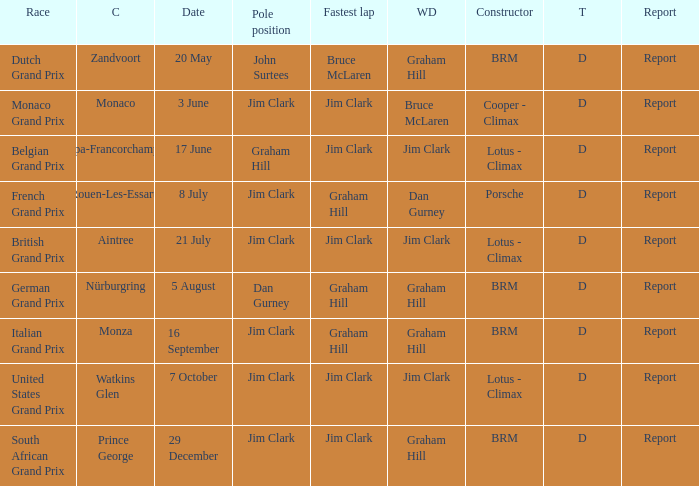What is the constructor at the United States Grand Prix? Lotus - Climax. Write the full table. {'header': ['Race', 'C', 'Date', 'Pole position', 'Fastest lap', 'WD', 'Constructor', 'T', 'Report'], 'rows': [['Dutch Grand Prix', 'Zandvoort', '20 May', 'John Surtees', 'Bruce McLaren', 'Graham Hill', 'BRM', 'D', 'Report'], ['Monaco Grand Prix', 'Monaco', '3 June', 'Jim Clark', 'Jim Clark', 'Bruce McLaren', 'Cooper - Climax', 'D', 'Report'], ['Belgian Grand Prix', 'Spa-Francorchamps', '17 June', 'Graham Hill', 'Jim Clark', 'Jim Clark', 'Lotus - Climax', 'D', 'Report'], ['French Grand Prix', 'Rouen-Les-Essarts', '8 July', 'Jim Clark', 'Graham Hill', 'Dan Gurney', 'Porsche', 'D', 'Report'], ['British Grand Prix', 'Aintree', '21 July', 'Jim Clark', 'Jim Clark', 'Jim Clark', 'Lotus - Climax', 'D', 'Report'], ['German Grand Prix', 'Nürburgring', '5 August', 'Dan Gurney', 'Graham Hill', 'Graham Hill', 'BRM', 'D', 'Report'], ['Italian Grand Prix', 'Monza', '16 September', 'Jim Clark', 'Graham Hill', 'Graham Hill', 'BRM', 'D', 'Report'], ['United States Grand Prix', 'Watkins Glen', '7 October', 'Jim Clark', 'Jim Clark', 'Jim Clark', 'Lotus - Climax', 'D', 'Report'], ['South African Grand Prix', 'Prince George', '29 December', 'Jim Clark', 'Jim Clark', 'Graham Hill', 'BRM', 'D', 'Report']]} 